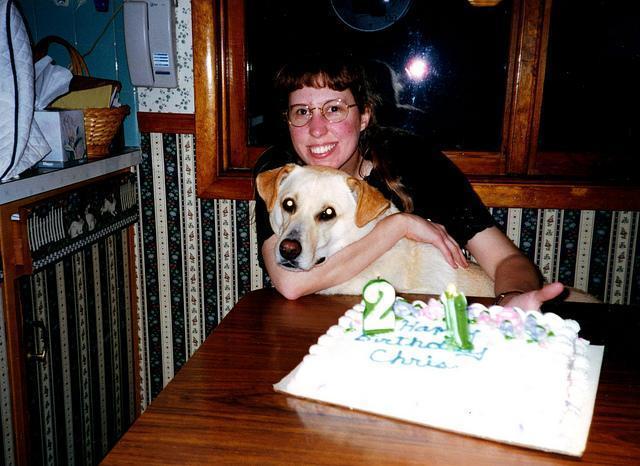How many dogs are in the photo?
Give a very brief answer. 1. How many bears are here?
Give a very brief answer. 0. 